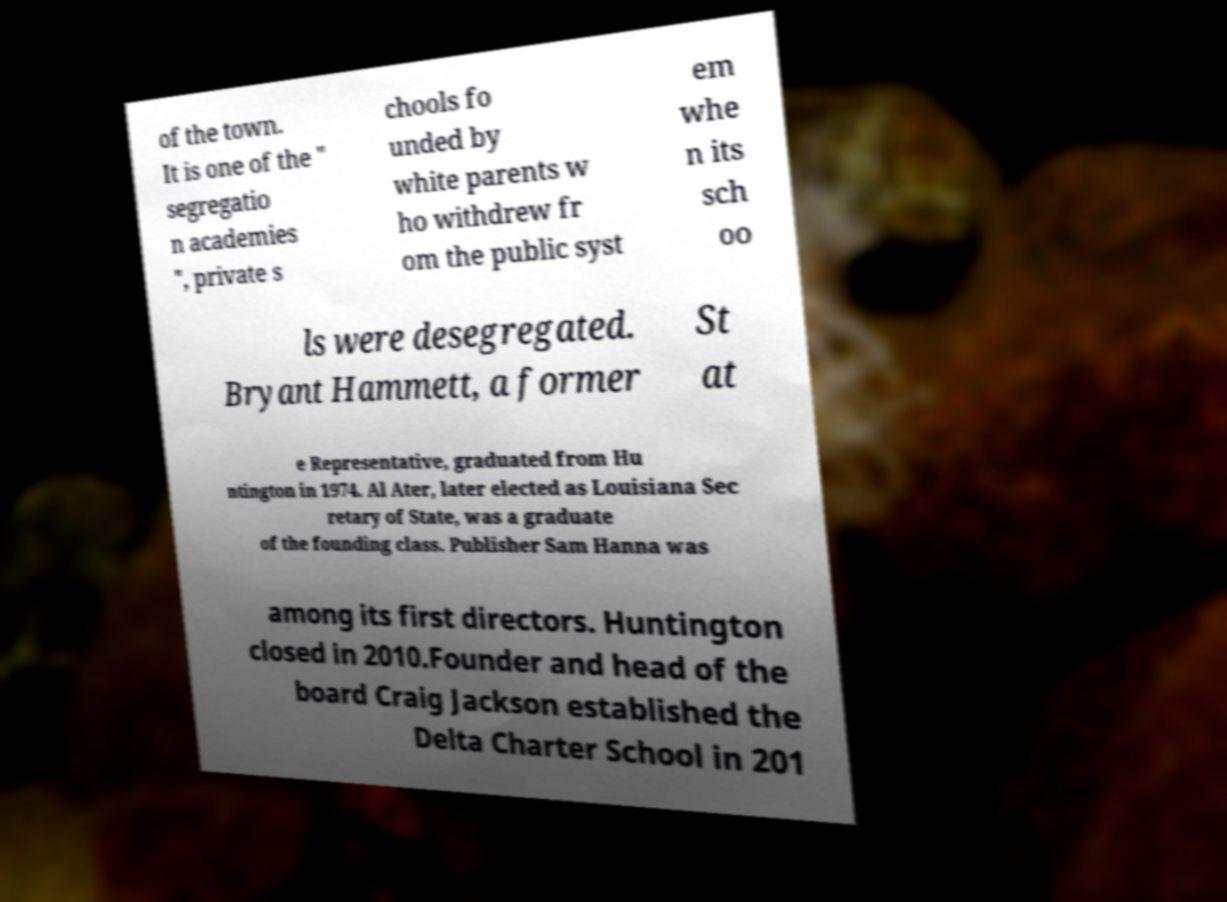I need the written content from this picture converted into text. Can you do that? of the town. It is one of the " segregatio n academies ", private s chools fo unded by white parents w ho withdrew fr om the public syst em whe n its sch oo ls were desegregated. Bryant Hammett, a former St at e Representative, graduated from Hu ntington in 1974. Al Ater, later elected as Louisiana Sec retary of State, was a graduate of the founding class. Publisher Sam Hanna was among its first directors. Huntington closed in 2010.Founder and head of the board Craig Jackson established the Delta Charter School in 201 